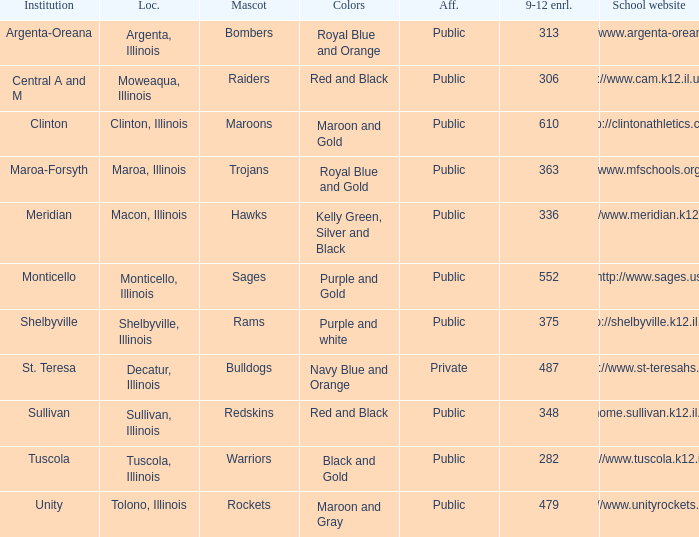What's the name of the city or town of the school that operates the http://www.mfschools.org/high/ website? Maroa-Forsyth. 